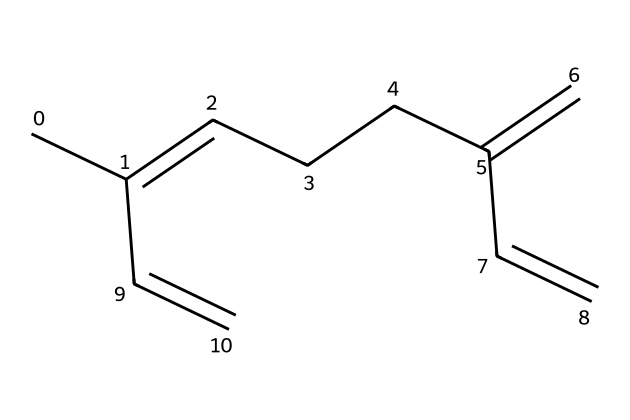What is the name of this chemical? The SMILES notation provided corresponds to myrcene, a terpene known for its citrusy and earthy aroma.
Answer: myrcene How many double bonds are present in myrcene? By analyzing the structure, we can identify the multiple double bonds indicated in the structure; there are three double bonds present in myrcene's carbon skeleton.
Answer: 3 What is the molecular formula of myrcene? Counting the number of carbon and hydrogen atoms from the SMILES representation shows myrcene consists of 10 carbon atoms and 16 hydrogen atoms, which together form the molecular formula C10H16.
Answer: C10H16 How is myrcene classified based on its structure? Myrcene is classified as a monoterpene because it contains two isoprene units, commonly recognized in the structure of terpenes.
Answer: monoterpene Which type of bonds are primarily present in myrcene? The structure contains carbon-carbon single and double bonds, which are characteristic of terpenes, contributing to their flexibility and reactivity.
Answer: carbon-carbon How does myrcene's structure relate to its aroma properties? The presence of specific functional groups and the arrangement of double bonds in the carbon chain influence the compound's volatility and therefore its aroma; this structure is linked to its aromatic profile of earthy and citrus notes.
Answer: aroma profile What role do terpenes like myrcene play in ancient perfumes? Terpenes like myrcene were often used in ancient perfumes due to their strong fragrances and natural sources, contributing to the scent complexity in these artifacts.
Answer: fragrance 